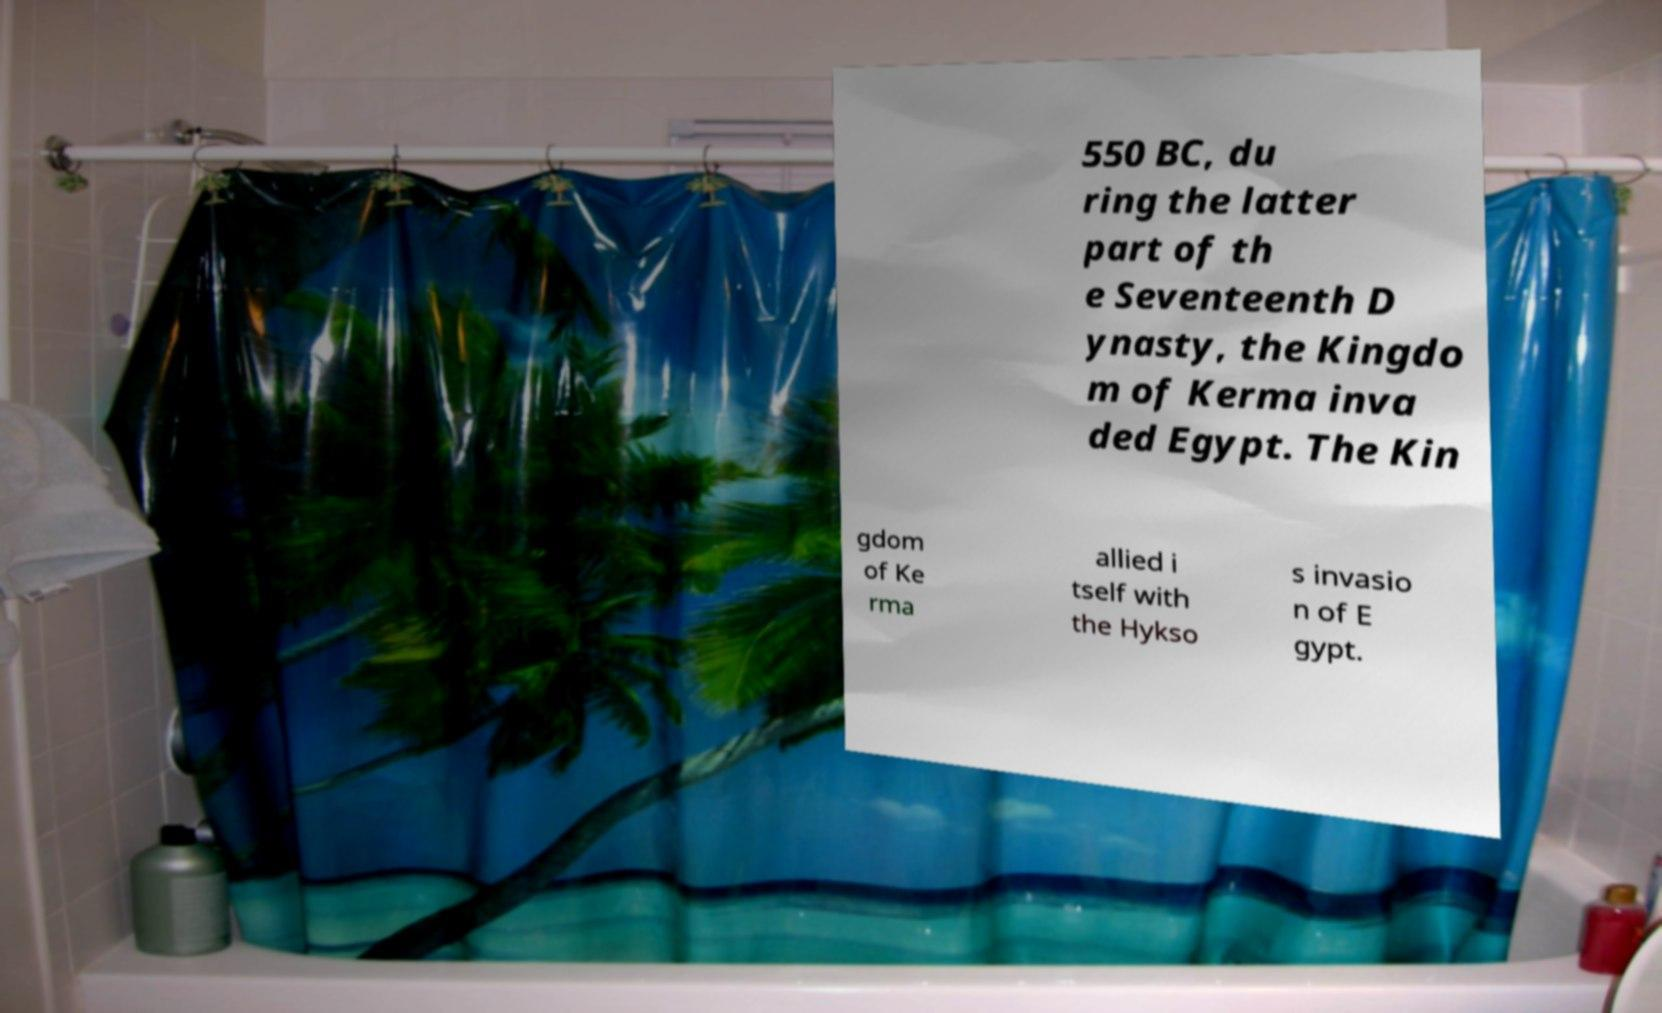Can you accurately transcribe the text from the provided image for me? 550 BC, du ring the latter part of th e Seventeenth D ynasty, the Kingdo m of Kerma inva ded Egypt. The Kin gdom of Ke rma allied i tself with the Hykso s invasio n of E gypt. 